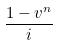<formula> <loc_0><loc_0><loc_500><loc_500>\frac { 1 - v ^ { n } } { i }</formula> 